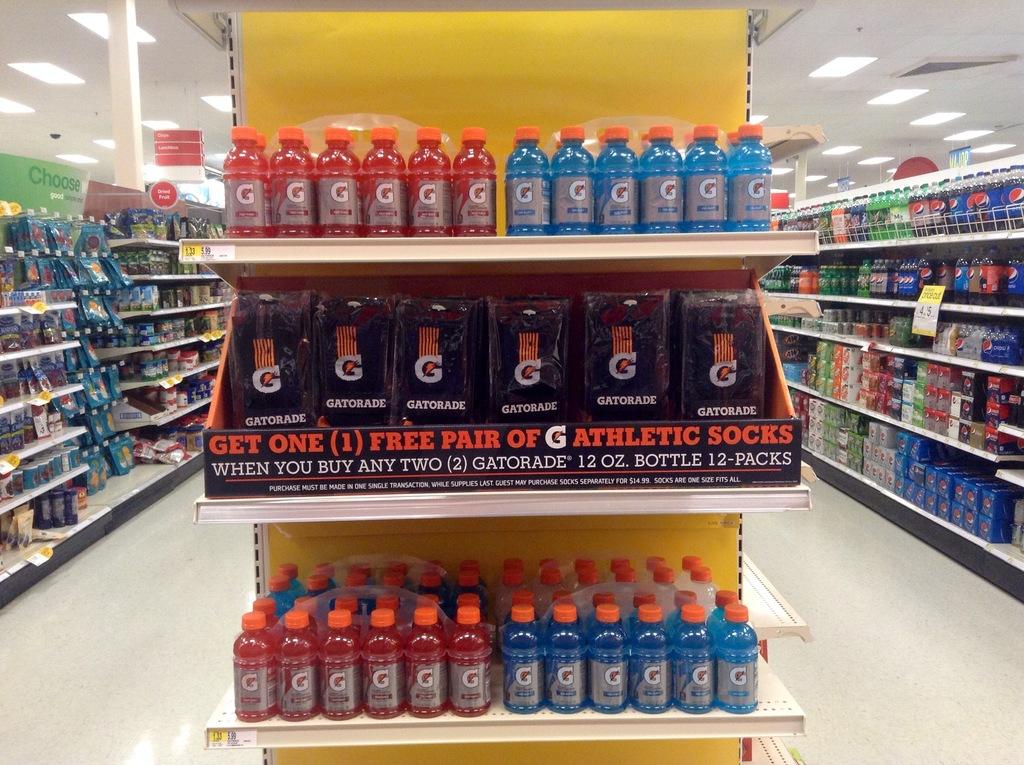What brand of sports drink is on this shelf?
Make the answer very short. Gatorade. What can you win?
Ensure brevity in your answer.  Athletic socks. 